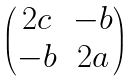<formula> <loc_0><loc_0><loc_500><loc_500>\begin{pmatrix} 2 c & - b \\ - b & 2 a \end{pmatrix}</formula> 